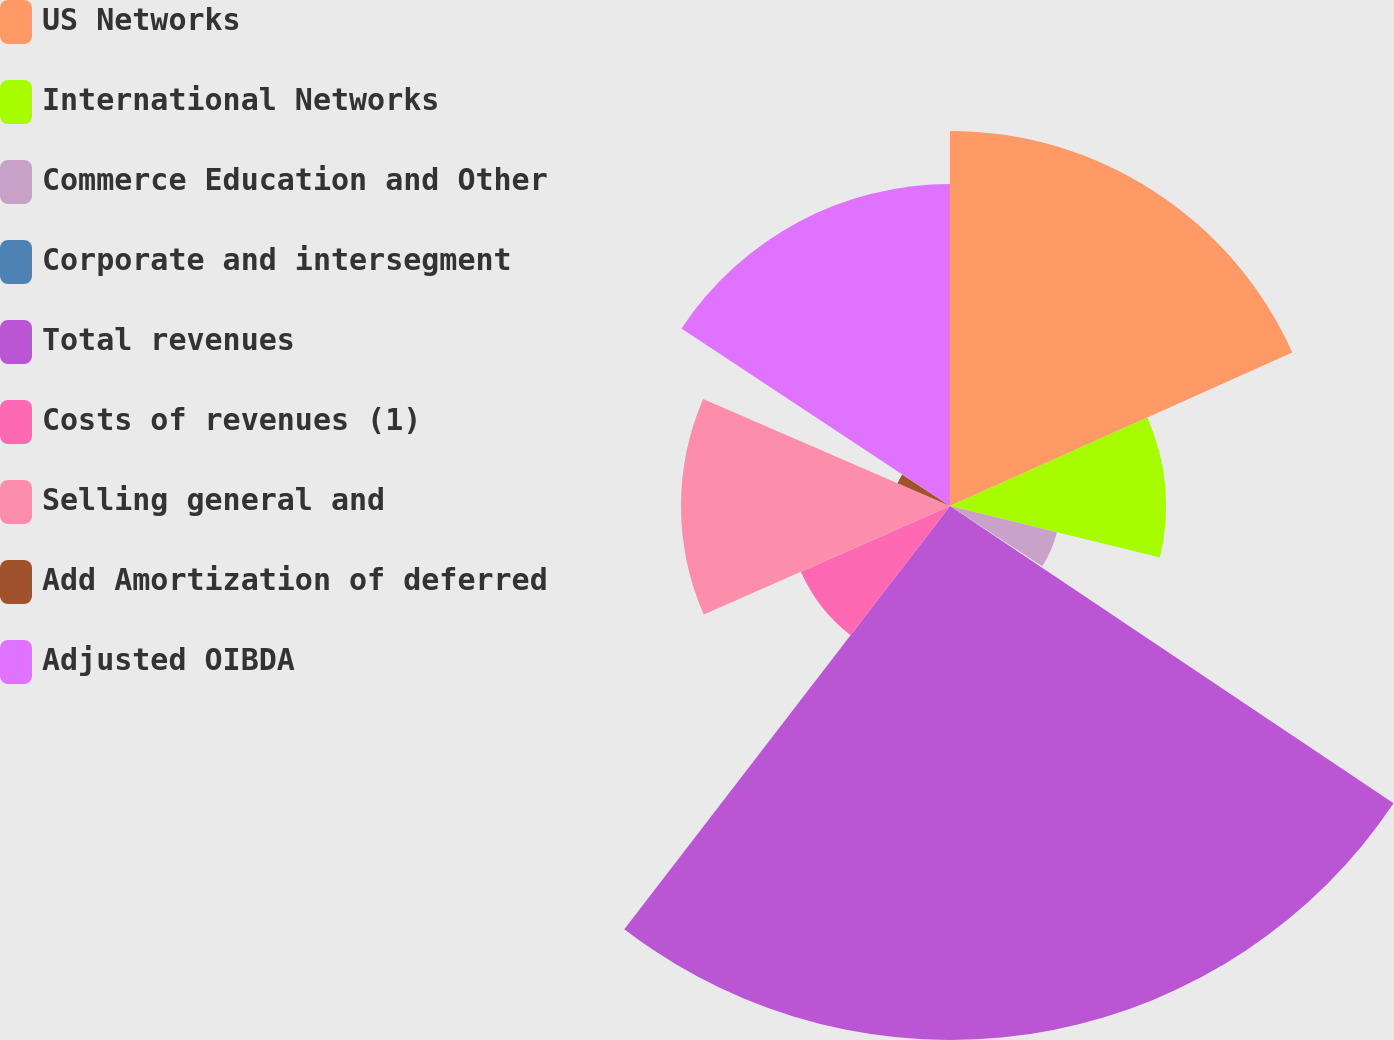<chart> <loc_0><loc_0><loc_500><loc_500><pie_chart><fcel>US Networks<fcel>International Networks<fcel>Commerce Education and Other<fcel>Corporate and intersegment<fcel>Total revenues<fcel>Costs of revenues (1)<fcel>Selling general and<fcel>Add Amortization of deferred<fcel>Adjusted OIBDA<nl><fcel>18.29%<fcel>10.54%<fcel>5.37%<fcel>0.2%<fcel>26.04%<fcel>7.95%<fcel>13.12%<fcel>2.79%<fcel>15.7%<nl></chart> 